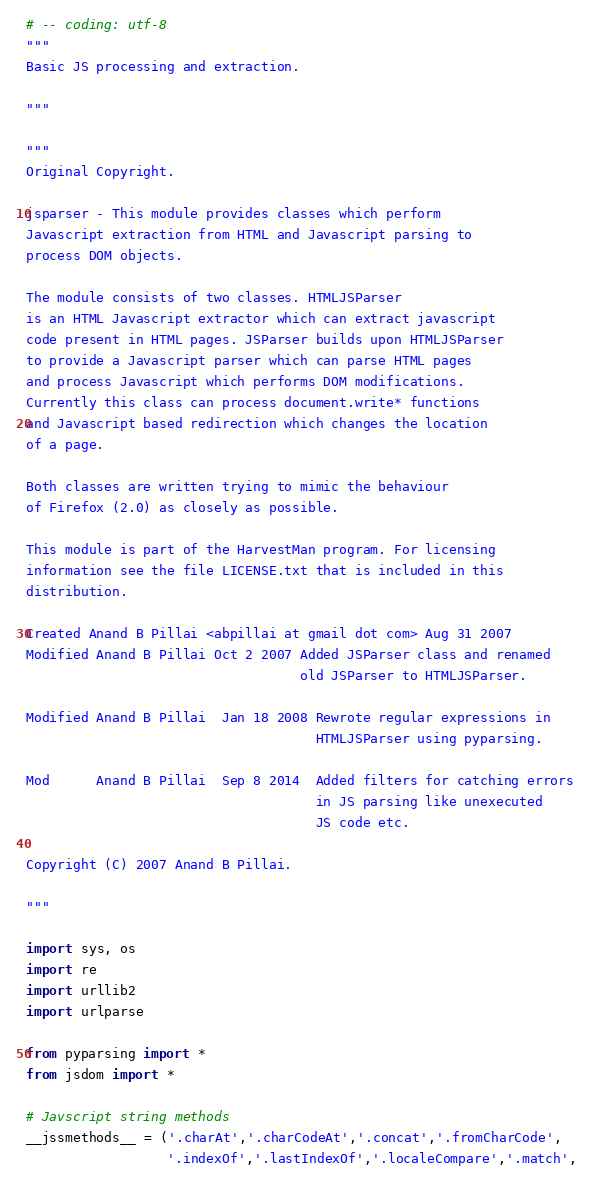<code> <loc_0><loc_0><loc_500><loc_500><_Python_># -- coding: utf-8
"""
Basic JS processing and extraction.

"""

"""
Original Copyright.

jsparser - This module provides classes which perform
Javascript extraction from HTML and Javascript parsing to
process DOM objects.

The module consists of two classes. HTMLJSParser
is an HTML Javascript extractor which can extract javascript
code present in HTML pages. JSParser builds upon HTMLJSParser
to provide a Javascript parser which can parse HTML pages
and process Javascript which performs DOM modifications.
Currently this class can process document.write* functions
and Javascript based redirection which changes the location
of a page.

Both classes are written trying to mimic the behaviour
of Firefox (2.0) as closely as possible.

This module is part of the HarvestMan program. For licensing
information see the file LICENSE.txt that is included in this
distribution.

Created Anand B Pillai <abpillai at gmail dot com> Aug 31 2007
Modified Anand B Pillai Oct 2 2007 Added JSParser class and renamed
                                   old JSParser to HTMLJSParser.

Modified Anand B Pillai  Jan 18 2008 Rewrote regular expressions in
                                     HTMLJSParser using pyparsing.

Mod      Anand B Pillai  Sep 8 2014  Added filters for catching errors
                                     in JS parsing like unexecuted
                                     JS code etc.

Copyright (C) 2007 Anand B Pillai.

"""

import sys, os
import re
import urllib2
import urlparse

from pyparsing import *
from jsdom import *

# Javscript string methods
__jssmethods__ = ('.charAt','.charCodeAt','.concat','.fromCharCode',
                  '.indexOf','.lastIndexOf','.localeCompare','.match',</code> 